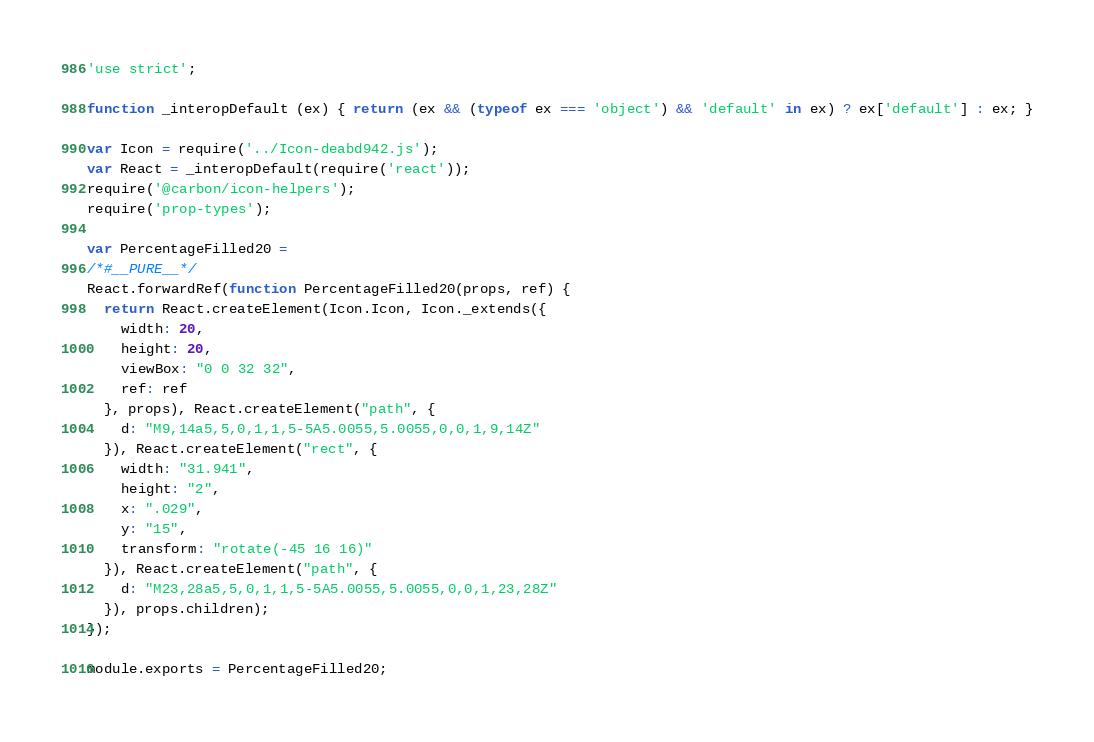<code> <loc_0><loc_0><loc_500><loc_500><_JavaScript_>'use strict';

function _interopDefault (ex) { return (ex && (typeof ex === 'object') && 'default' in ex) ? ex['default'] : ex; }

var Icon = require('../Icon-deabd942.js');
var React = _interopDefault(require('react'));
require('@carbon/icon-helpers');
require('prop-types');

var PercentageFilled20 =
/*#__PURE__*/
React.forwardRef(function PercentageFilled20(props, ref) {
  return React.createElement(Icon.Icon, Icon._extends({
    width: 20,
    height: 20,
    viewBox: "0 0 32 32",
    ref: ref
  }, props), React.createElement("path", {
    d: "M9,14a5,5,0,1,1,5-5A5.0055,5.0055,0,0,1,9,14Z"
  }), React.createElement("rect", {
    width: "31.941",
    height: "2",
    x: ".029",
    y: "15",
    transform: "rotate(-45 16 16)"
  }), React.createElement("path", {
    d: "M23,28a5,5,0,1,1,5-5A5.0055,5.0055,0,0,1,23,28Z"
  }), props.children);
});

module.exports = PercentageFilled20;
</code> 